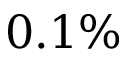<formula> <loc_0><loc_0><loc_500><loc_500>0 . 1 \%</formula> 